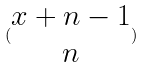Convert formula to latex. <formula><loc_0><loc_0><loc_500><loc_500>( \begin{matrix} x + n - 1 \\ n \end{matrix} )</formula> 